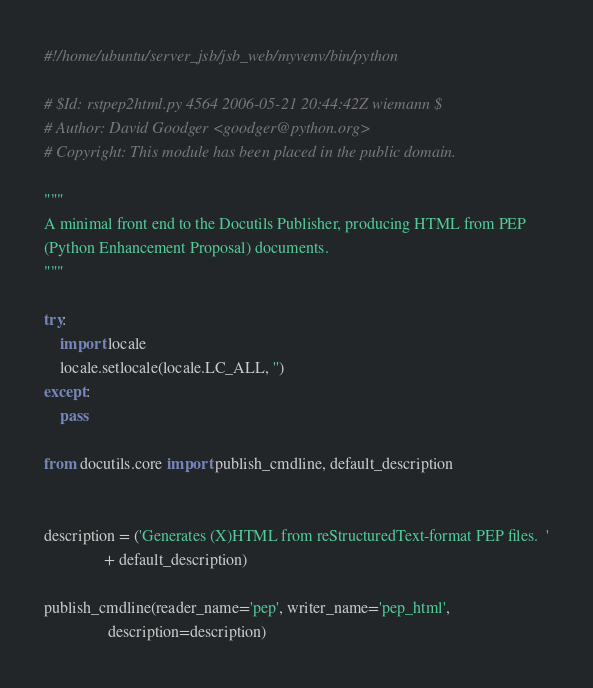<code> <loc_0><loc_0><loc_500><loc_500><_Python_>#!/home/ubuntu/server_jsb/jsb_web/myvenv/bin/python

# $Id: rstpep2html.py 4564 2006-05-21 20:44:42Z wiemann $
# Author: David Goodger <goodger@python.org>
# Copyright: This module has been placed in the public domain.

"""
A minimal front end to the Docutils Publisher, producing HTML from PEP
(Python Enhancement Proposal) documents.
"""

try:
    import locale
    locale.setlocale(locale.LC_ALL, '')
except:
    pass

from docutils.core import publish_cmdline, default_description


description = ('Generates (X)HTML from reStructuredText-format PEP files.  '
               + default_description)

publish_cmdline(reader_name='pep', writer_name='pep_html',
                description=description)
</code> 